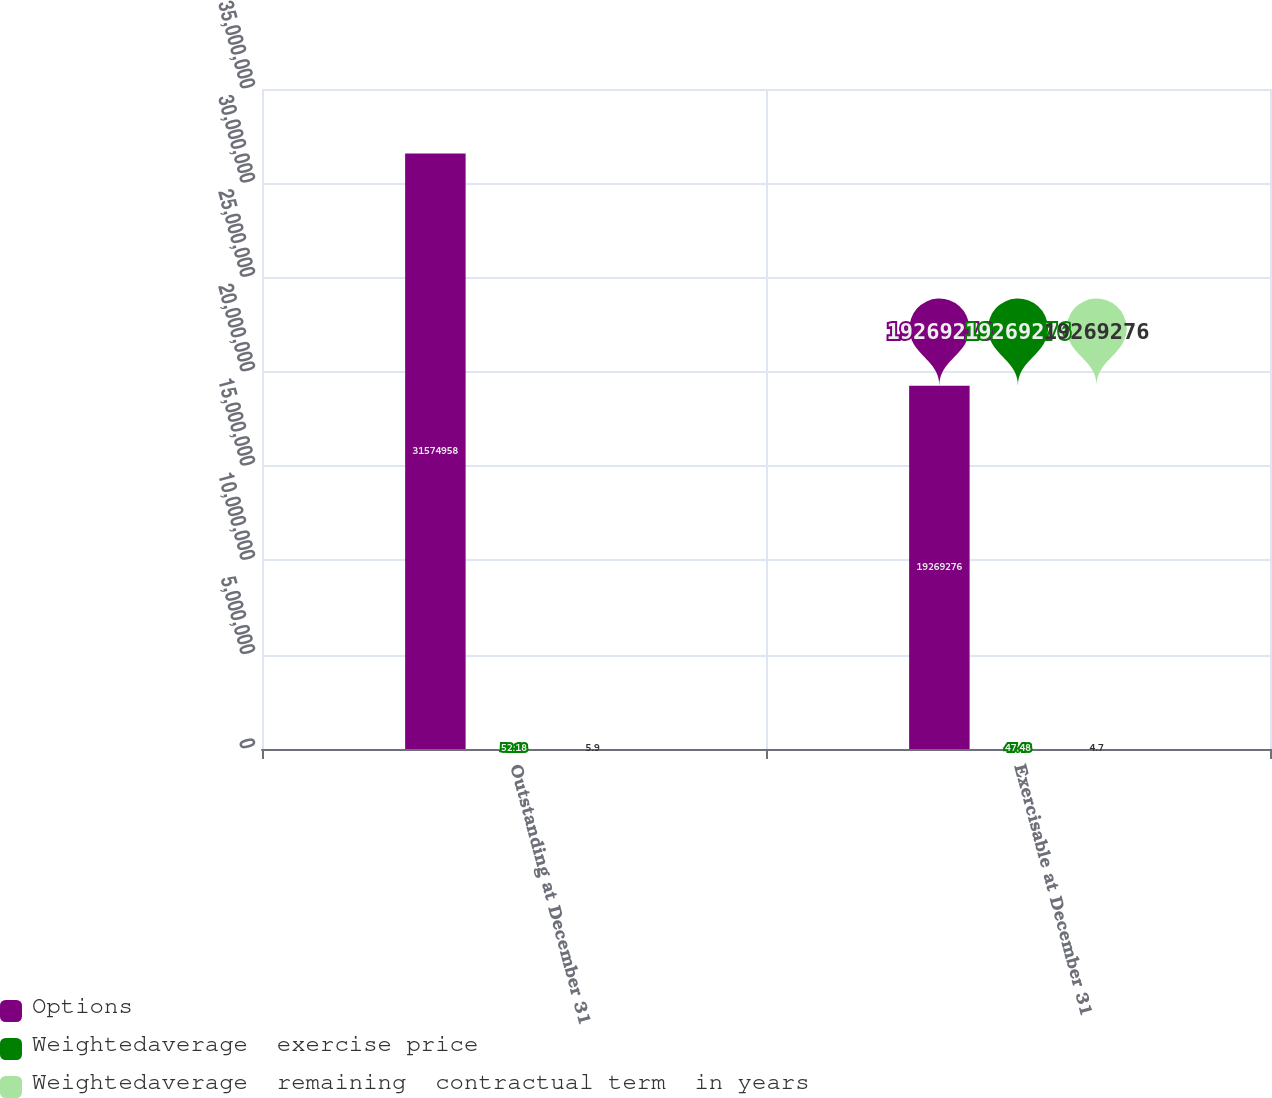Convert chart to OTSL. <chart><loc_0><loc_0><loc_500><loc_500><stacked_bar_chart><ecel><fcel>Outstanding at December 31<fcel>Exercisable at December 31<nl><fcel>Options<fcel>3.1575e+07<fcel>1.92693e+07<nl><fcel>Weightedaverage  exercise price<fcel>52.18<fcel>47.48<nl><fcel>Weightedaverage  remaining  contractual term  in years<fcel>5.9<fcel>4.7<nl></chart> 